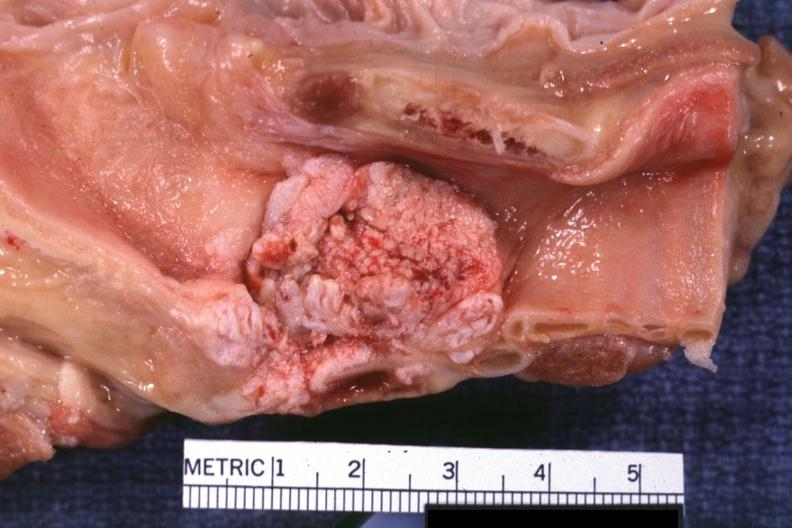s larynx present?
Answer the question using a single word or phrase. Yes 